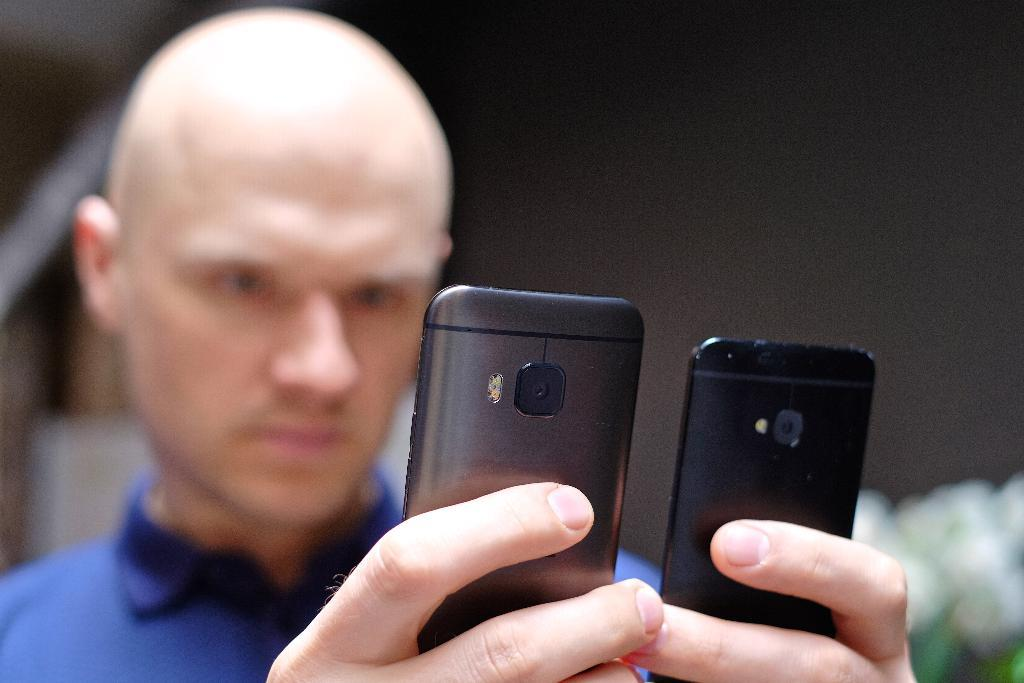What is the main subject of the image? The main subject of the image is a man. What is the man holding in the image? The man is holding mobile phones in the image. What can be said about the color of the mobile phones? The mobile phones are black in color. What is the man wearing in the image? The man is wearing a blue shirt in the image. What type of pie is being served at the zoo in the image? There is no pie or zoo present in the image; it features a man holding black mobile phones while wearing a blue shirt. 